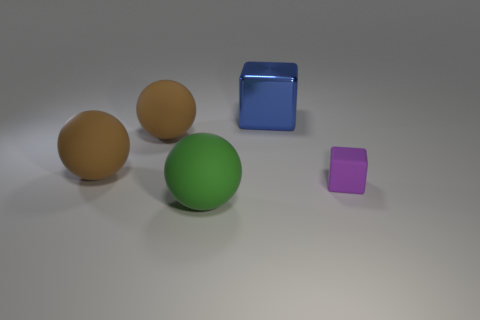Are there any other things that are the same size as the purple cube?
Provide a succinct answer. No. There is a thing that is both on the right side of the green rubber ball and to the left of the tiny purple thing; what is its material?
Offer a terse response. Metal. There is a large green thing that is made of the same material as the purple cube; what is its shape?
Ensure brevity in your answer.  Sphere. The green ball that is made of the same material as the purple block is what size?
Give a very brief answer. Large. The object that is to the right of the green rubber ball and behind the tiny purple cube has what shape?
Give a very brief answer. Cube. What is the size of the block that is behind the block that is in front of the shiny cube?
Keep it short and to the point. Large. What material is the green ball?
Provide a short and direct response. Rubber. Is there a matte block?
Offer a very short reply. Yes. Is the number of purple objects that are to the left of the large blue shiny cube the same as the number of large metal cubes?
Your answer should be very brief. No. Is there any other thing that has the same material as the small purple cube?
Ensure brevity in your answer.  Yes. 